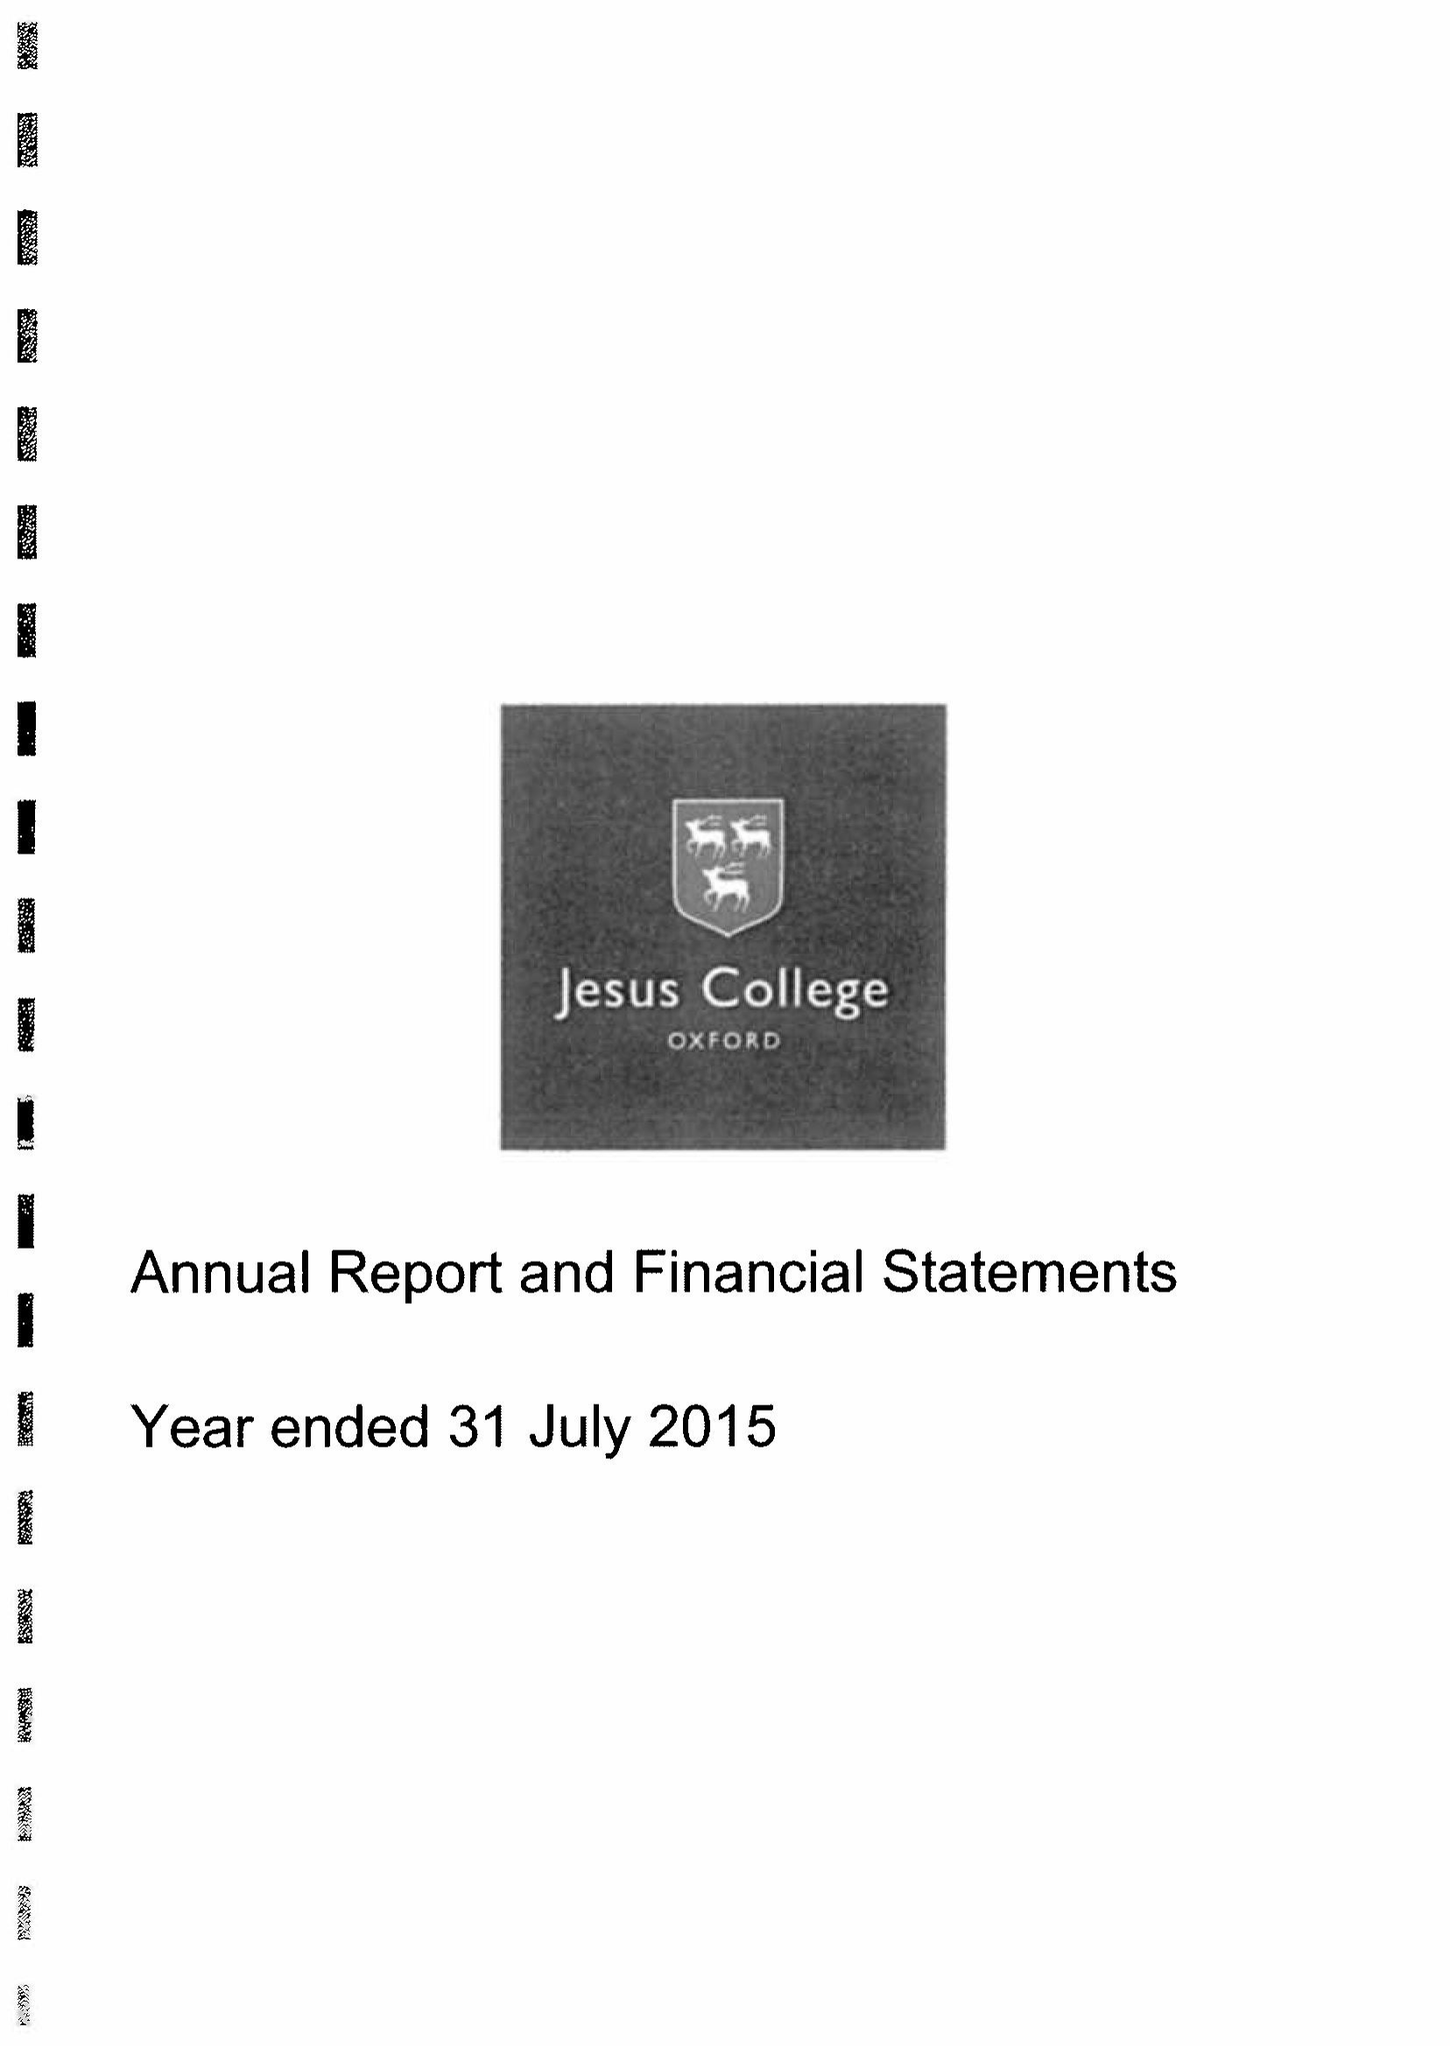What is the value for the address__post_town?
Answer the question using a single word or phrase. OXFORD 